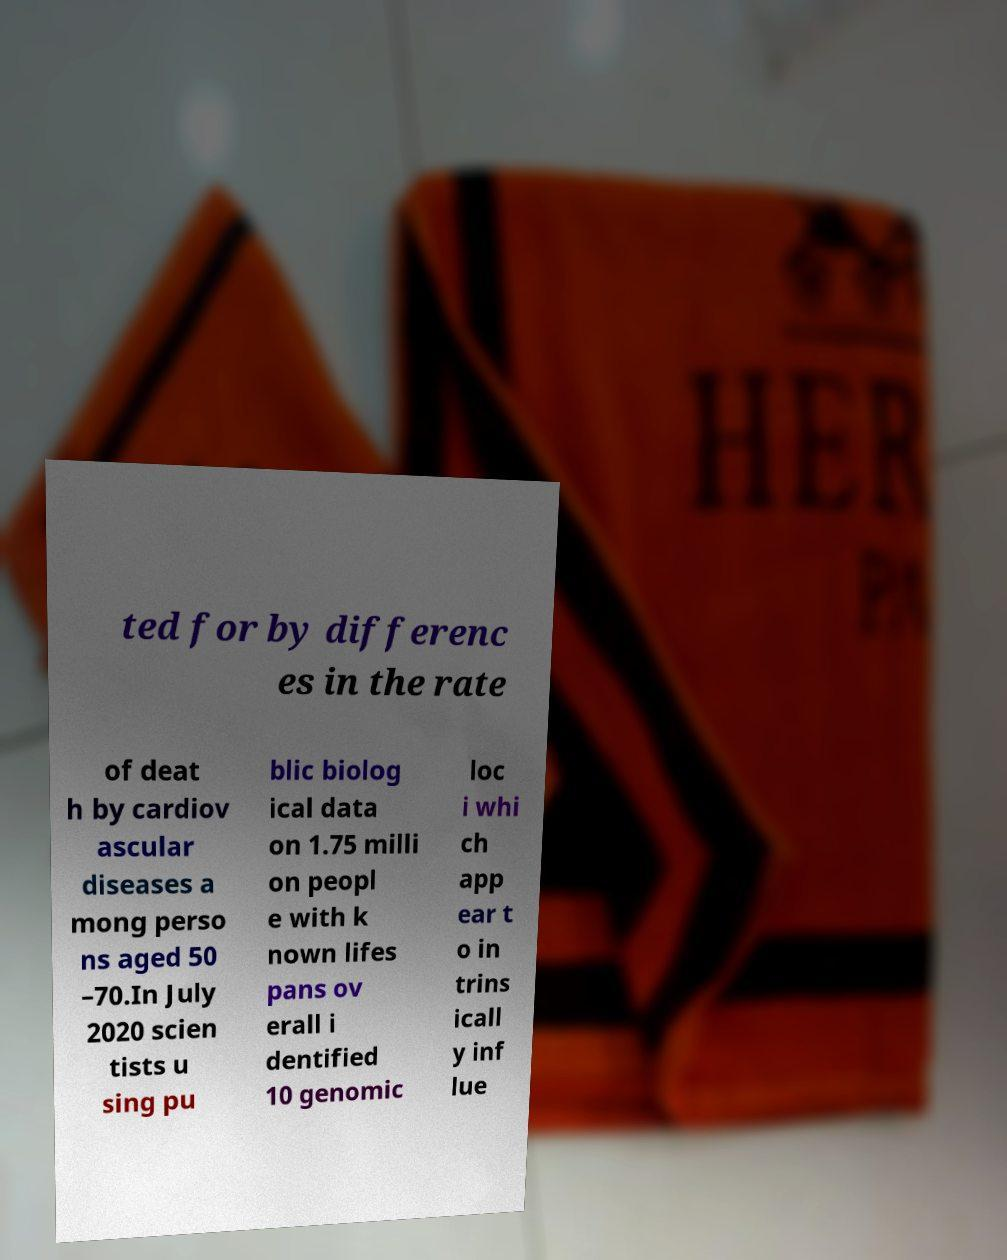Could you extract and type out the text from this image? ted for by differenc es in the rate of deat h by cardiov ascular diseases a mong perso ns aged 50 –70.In July 2020 scien tists u sing pu blic biolog ical data on 1.75 milli on peopl e with k nown lifes pans ov erall i dentified 10 genomic loc i whi ch app ear t o in trins icall y inf lue 